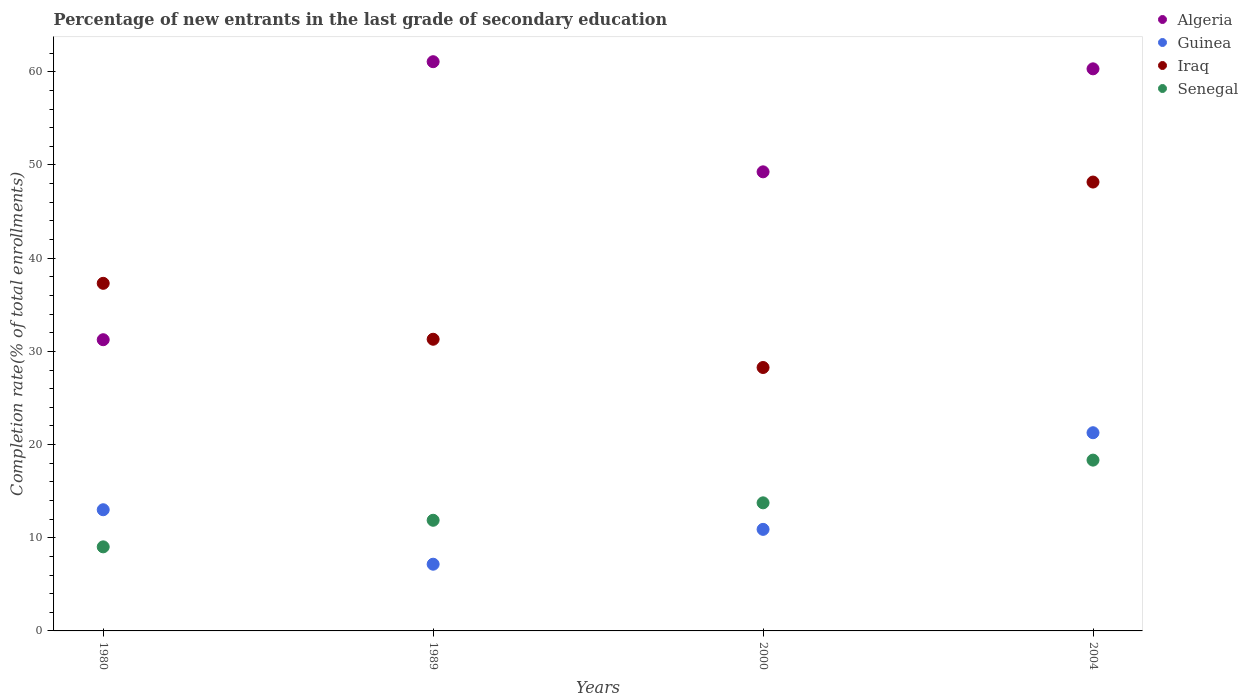How many different coloured dotlines are there?
Make the answer very short. 4. Is the number of dotlines equal to the number of legend labels?
Provide a succinct answer. Yes. What is the percentage of new entrants in Guinea in 1980?
Make the answer very short. 13. Across all years, what is the maximum percentage of new entrants in Iraq?
Offer a very short reply. 48.17. Across all years, what is the minimum percentage of new entrants in Algeria?
Provide a succinct answer. 31.25. In which year was the percentage of new entrants in Iraq maximum?
Provide a short and direct response. 2004. In which year was the percentage of new entrants in Algeria minimum?
Your response must be concise. 1980. What is the total percentage of new entrants in Senegal in the graph?
Your answer should be compact. 52.97. What is the difference between the percentage of new entrants in Senegal in 1989 and that in 2004?
Ensure brevity in your answer.  -6.45. What is the difference between the percentage of new entrants in Senegal in 2004 and the percentage of new entrants in Iraq in 1980?
Offer a terse response. -18.97. What is the average percentage of new entrants in Iraq per year?
Your answer should be compact. 36.26. In the year 1980, what is the difference between the percentage of new entrants in Senegal and percentage of new entrants in Iraq?
Offer a terse response. -28.28. What is the ratio of the percentage of new entrants in Senegal in 2000 to that in 2004?
Your response must be concise. 0.75. What is the difference between the highest and the second highest percentage of new entrants in Algeria?
Offer a terse response. 0.77. What is the difference between the highest and the lowest percentage of new entrants in Algeria?
Your answer should be very brief. 29.83. In how many years, is the percentage of new entrants in Iraq greater than the average percentage of new entrants in Iraq taken over all years?
Offer a terse response. 2. Is it the case that in every year, the sum of the percentage of new entrants in Iraq and percentage of new entrants in Guinea  is greater than the sum of percentage of new entrants in Senegal and percentage of new entrants in Algeria?
Provide a short and direct response. No. Is the percentage of new entrants in Guinea strictly greater than the percentage of new entrants in Algeria over the years?
Provide a succinct answer. No. Is the percentage of new entrants in Senegal strictly less than the percentage of new entrants in Guinea over the years?
Provide a succinct answer. No. How many years are there in the graph?
Make the answer very short. 4. Are the values on the major ticks of Y-axis written in scientific E-notation?
Keep it short and to the point. No. Does the graph contain grids?
Provide a short and direct response. No. Where does the legend appear in the graph?
Ensure brevity in your answer.  Top right. How are the legend labels stacked?
Provide a short and direct response. Vertical. What is the title of the graph?
Offer a very short reply. Percentage of new entrants in the last grade of secondary education. Does "Lower middle income" appear as one of the legend labels in the graph?
Offer a very short reply. No. What is the label or title of the X-axis?
Provide a succinct answer. Years. What is the label or title of the Y-axis?
Keep it short and to the point. Completion rate(% of total enrollments). What is the Completion rate(% of total enrollments) in Algeria in 1980?
Provide a short and direct response. 31.25. What is the Completion rate(% of total enrollments) of Guinea in 1980?
Give a very brief answer. 13. What is the Completion rate(% of total enrollments) in Iraq in 1980?
Ensure brevity in your answer.  37.3. What is the Completion rate(% of total enrollments) of Senegal in 1980?
Keep it short and to the point. 9.02. What is the Completion rate(% of total enrollments) in Algeria in 1989?
Your response must be concise. 61.08. What is the Completion rate(% of total enrollments) of Guinea in 1989?
Ensure brevity in your answer.  7.16. What is the Completion rate(% of total enrollments) of Iraq in 1989?
Offer a very short reply. 31.3. What is the Completion rate(% of total enrollments) of Senegal in 1989?
Offer a very short reply. 11.87. What is the Completion rate(% of total enrollments) in Algeria in 2000?
Offer a very short reply. 49.27. What is the Completion rate(% of total enrollments) in Guinea in 2000?
Ensure brevity in your answer.  10.9. What is the Completion rate(% of total enrollments) of Iraq in 2000?
Offer a very short reply. 28.27. What is the Completion rate(% of total enrollments) of Senegal in 2000?
Your answer should be compact. 13.74. What is the Completion rate(% of total enrollments) of Algeria in 2004?
Ensure brevity in your answer.  60.32. What is the Completion rate(% of total enrollments) of Guinea in 2004?
Make the answer very short. 21.27. What is the Completion rate(% of total enrollments) in Iraq in 2004?
Your answer should be compact. 48.17. What is the Completion rate(% of total enrollments) of Senegal in 2004?
Your answer should be compact. 18.33. Across all years, what is the maximum Completion rate(% of total enrollments) of Algeria?
Keep it short and to the point. 61.08. Across all years, what is the maximum Completion rate(% of total enrollments) in Guinea?
Ensure brevity in your answer.  21.27. Across all years, what is the maximum Completion rate(% of total enrollments) of Iraq?
Your response must be concise. 48.17. Across all years, what is the maximum Completion rate(% of total enrollments) of Senegal?
Offer a very short reply. 18.33. Across all years, what is the minimum Completion rate(% of total enrollments) in Algeria?
Provide a succinct answer. 31.25. Across all years, what is the minimum Completion rate(% of total enrollments) in Guinea?
Your answer should be very brief. 7.16. Across all years, what is the minimum Completion rate(% of total enrollments) in Iraq?
Offer a terse response. 28.27. Across all years, what is the minimum Completion rate(% of total enrollments) in Senegal?
Offer a terse response. 9.02. What is the total Completion rate(% of total enrollments) in Algeria in the graph?
Offer a very short reply. 201.92. What is the total Completion rate(% of total enrollments) in Guinea in the graph?
Your answer should be very brief. 52.33. What is the total Completion rate(% of total enrollments) in Iraq in the graph?
Offer a very short reply. 145.04. What is the total Completion rate(% of total enrollments) of Senegal in the graph?
Offer a very short reply. 52.97. What is the difference between the Completion rate(% of total enrollments) in Algeria in 1980 and that in 1989?
Your answer should be very brief. -29.83. What is the difference between the Completion rate(% of total enrollments) in Guinea in 1980 and that in 1989?
Your answer should be compact. 5.84. What is the difference between the Completion rate(% of total enrollments) in Iraq in 1980 and that in 1989?
Keep it short and to the point. 6. What is the difference between the Completion rate(% of total enrollments) of Senegal in 1980 and that in 1989?
Offer a terse response. -2.85. What is the difference between the Completion rate(% of total enrollments) of Algeria in 1980 and that in 2000?
Keep it short and to the point. -18.02. What is the difference between the Completion rate(% of total enrollments) in Guinea in 1980 and that in 2000?
Your answer should be compact. 2.11. What is the difference between the Completion rate(% of total enrollments) in Iraq in 1980 and that in 2000?
Ensure brevity in your answer.  9.03. What is the difference between the Completion rate(% of total enrollments) in Senegal in 1980 and that in 2000?
Ensure brevity in your answer.  -4.72. What is the difference between the Completion rate(% of total enrollments) in Algeria in 1980 and that in 2004?
Offer a very short reply. -29.07. What is the difference between the Completion rate(% of total enrollments) in Guinea in 1980 and that in 2004?
Offer a very short reply. -8.26. What is the difference between the Completion rate(% of total enrollments) in Iraq in 1980 and that in 2004?
Your answer should be compact. -10.87. What is the difference between the Completion rate(% of total enrollments) of Senegal in 1980 and that in 2004?
Your answer should be compact. -9.31. What is the difference between the Completion rate(% of total enrollments) of Algeria in 1989 and that in 2000?
Provide a short and direct response. 11.82. What is the difference between the Completion rate(% of total enrollments) of Guinea in 1989 and that in 2000?
Provide a short and direct response. -3.74. What is the difference between the Completion rate(% of total enrollments) of Iraq in 1989 and that in 2000?
Ensure brevity in your answer.  3.03. What is the difference between the Completion rate(% of total enrollments) of Senegal in 1989 and that in 2000?
Give a very brief answer. -1.87. What is the difference between the Completion rate(% of total enrollments) of Algeria in 1989 and that in 2004?
Offer a terse response. 0.77. What is the difference between the Completion rate(% of total enrollments) of Guinea in 1989 and that in 2004?
Ensure brevity in your answer.  -14.11. What is the difference between the Completion rate(% of total enrollments) in Iraq in 1989 and that in 2004?
Provide a short and direct response. -16.87. What is the difference between the Completion rate(% of total enrollments) in Senegal in 1989 and that in 2004?
Ensure brevity in your answer.  -6.45. What is the difference between the Completion rate(% of total enrollments) of Algeria in 2000 and that in 2004?
Your answer should be very brief. -11.05. What is the difference between the Completion rate(% of total enrollments) of Guinea in 2000 and that in 2004?
Give a very brief answer. -10.37. What is the difference between the Completion rate(% of total enrollments) in Iraq in 2000 and that in 2004?
Give a very brief answer. -19.9. What is the difference between the Completion rate(% of total enrollments) in Senegal in 2000 and that in 2004?
Your answer should be very brief. -4.58. What is the difference between the Completion rate(% of total enrollments) of Algeria in 1980 and the Completion rate(% of total enrollments) of Guinea in 1989?
Offer a very short reply. 24.09. What is the difference between the Completion rate(% of total enrollments) in Algeria in 1980 and the Completion rate(% of total enrollments) in Iraq in 1989?
Your answer should be compact. -0.05. What is the difference between the Completion rate(% of total enrollments) in Algeria in 1980 and the Completion rate(% of total enrollments) in Senegal in 1989?
Ensure brevity in your answer.  19.38. What is the difference between the Completion rate(% of total enrollments) in Guinea in 1980 and the Completion rate(% of total enrollments) in Iraq in 1989?
Your answer should be very brief. -18.3. What is the difference between the Completion rate(% of total enrollments) of Guinea in 1980 and the Completion rate(% of total enrollments) of Senegal in 1989?
Offer a very short reply. 1.13. What is the difference between the Completion rate(% of total enrollments) in Iraq in 1980 and the Completion rate(% of total enrollments) in Senegal in 1989?
Give a very brief answer. 25.43. What is the difference between the Completion rate(% of total enrollments) in Algeria in 1980 and the Completion rate(% of total enrollments) in Guinea in 2000?
Your answer should be compact. 20.35. What is the difference between the Completion rate(% of total enrollments) in Algeria in 1980 and the Completion rate(% of total enrollments) in Iraq in 2000?
Ensure brevity in your answer.  2.98. What is the difference between the Completion rate(% of total enrollments) of Algeria in 1980 and the Completion rate(% of total enrollments) of Senegal in 2000?
Give a very brief answer. 17.5. What is the difference between the Completion rate(% of total enrollments) in Guinea in 1980 and the Completion rate(% of total enrollments) in Iraq in 2000?
Offer a very short reply. -15.26. What is the difference between the Completion rate(% of total enrollments) in Guinea in 1980 and the Completion rate(% of total enrollments) in Senegal in 2000?
Your response must be concise. -0.74. What is the difference between the Completion rate(% of total enrollments) in Iraq in 1980 and the Completion rate(% of total enrollments) in Senegal in 2000?
Ensure brevity in your answer.  23.56. What is the difference between the Completion rate(% of total enrollments) of Algeria in 1980 and the Completion rate(% of total enrollments) of Guinea in 2004?
Give a very brief answer. 9.98. What is the difference between the Completion rate(% of total enrollments) in Algeria in 1980 and the Completion rate(% of total enrollments) in Iraq in 2004?
Your answer should be very brief. -16.92. What is the difference between the Completion rate(% of total enrollments) of Algeria in 1980 and the Completion rate(% of total enrollments) of Senegal in 2004?
Keep it short and to the point. 12.92. What is the difference between the Completion rate(% of total enrollments) of Guinea in 1980 and the Completion rate(% of total enrollments) of Iraq in 2004?
Offer a very short reply. -35.16. What is the difference between the Completion rate(% of total enrollments) of Guinea in 1980 and the Completion rate(% of total enrollments) of Senegal in 2004?
Give a very brief answer. -5.33. What is the difference between the Completion rate(% of total enrollments) in Iraq in 1980 and the Completion rate(% of total enrollments) in Senegal in 2004?
Your answer should be very brief. 18.97. What is the difference between the Completion rate(% of total enrollments) of Algeria in 1989 and the Completion rate(% of total enrollments) of Guinea in 2000?
Make the answer very short. 50.19. What is the difference between the Completion rate(% of total enrollments) of Algeria in 1989 and the Completion rate(% of total enrollments) of Iraq in 2000?
Your answer should be compact. 32.82. What is the difference between the Completion rate(% of total enrollments) in Algeria in 1989 and the Completion rate(% of total enrollments) in Senegal in 2000?
Offer a terse response. 47.34. What is the difference between the Completion rate(% of total enrollments) in Guinea in 1989 and the Completion rate(% of total enrollments) in Iraq in 2000?
Provide a short and direct response. -21.11. What is the difference between the Completion rate(% of total enrollments) of Guinea in 1989 and the Completion rate(% of total enrollments) of Senegal in 2000?
Ensure brevity in your answer.  -6.59. What is the difference between the Completion rate(% of total enrollments) of Iraq in 1989 and the Completion rate(% of total enrollments) of Senegal in 2000?
Give a very brief answer. 17.55. What is the difference between the Completion rate(% of total enrollments) in Algeria in 1989 and the Completion rate(% of total enrollments) in Guinea in 2004?
Give a very brief answer. 39.82. What is the difference between the Completion rate(% of total enrollments) of Algeria in 1989 and the Completion rate(% of total enrollments) of Iraq in 2004?
Give a very brief answer. 12.92. What is the difference between the Completion rate(% of total enrollments) in Algeria in 1989 and the Completion rate(% of total enrollments) in Senegal in 2004?
Provide a succinct answer. 42.76. What is the difference between the Completion rate(% of total enrollments) of Guinea in 1989 and the Completion rate(% of total enrollments) of Iraq in 2004?
Your response must be concise. -41.01. What is the difference between the Completion rate(% of total enrollments) of Guinea in 1989 and the Completion rate(% of total enrollments) of Senegal in 2004?
Make the answer very short. -11.17. What is the difference between the Completion rate(% of total enrollments) in Iraq in 1989 and the Completion rate(% of total enrollments) in Senegal in 2004?
Offer a very short reply. 12.97. What is the difference between the Completion rate(% of total enrollments) in Algeria in 2000 and the Completion rate(% of total enrollments) in Guinea in 2004?
Keep it short and to the point. 28. What is the difference between the Completion rate(% of total enrollments) of Algeria in 2000 and the Completion rate(% of total enrollments) of Iraq in 2004?
Ensure brevity in your answer.  1.1. What is the difference between the Completion rate(% of total enrollments) in Algeria in 2000 and the Completion rate(% of total enrollments) in Senegal in 2004?
Provide a short and direct response. 30.94. What is the difference between the Completion rate(% of total enrollments) of Guinea in 2000 and the Completion rate(% of total enrollments) of Iraq in 2004?
Keep it short and to the point. -37.27. What is the difference between the Completion rate(% of total enrollments) in Guinea in 2000 and the Completion rate(% of total enrollments) in Senegal in 2004?
Your answer should be very brief. -7.43. What is the difference between the Completion rate(% of total enrollments) of Iraq in 2000 and the Completion rate(% of total enrollments) of Senegal in 2004?
Offer a terse response. 9.94. What is the average Completion rate(% of total enrollments) of Algeria per year?
Offer a terse response. 50.48. What is the average Completion rate(% of total enrollments) of Guinea per year?
Provide a succinct answer. 13.08. What is the average Completion rate(% of total enrollments) in Iraq per year?
Your response must be concise. 36.26. What is the average Completion rate(% of total enrollments) of Senegal per year?
Make the answer very short. 13.24. In the year 1980, what is the difference between the Completion rate(% of total enrollments) in Algeria and Completion rate(% of total enrollments) in Guinea?
Your response must be concise. 18.25. In the year 1980, what is the difference between the Completion rate(% of total enrollments) in Algeria and Completion rate(% of total enrollments) in Iraq?
Offer a very short reply. -6.05. In the year 1980, what is the difference between the Completion rate(% of total enrollments) of Algeria and Completion rate(% of total enrollments) of Senegal?
Offer a terse response. 22.23. In the year 1980, what is the difference between the Completion rate(% of total enrollments) in Guinea and Completion rate(% of total enrollments) in Iraq?
Give a very brief answer. -24.3. In the year 1980, what is the difference between the Completion rate(% of total enrollments) in Guinea and Completion rate(% of total enrollments) in Senegal?
Your answer should be compact. 3.98. In the year 1980, what is the difference between the Completion rate(% of total enrollments) of Iraq and Completion rate(% of total enrollments) of Senegal?
Your response must be concise. 28.28. In the year 1989, what is the difference between the Completion rate(% of total enrollments) of Algeria and Completion rate(% of total enrollments) of Guinea?
Give a very brief answer. 53.93. In the year 1989, what is the difference between the Completion rate(% of total enrollments) in Algeria and Completion rate(% of total enrollments) in Iraq?
Provide a short and direct response. 29.78. In the year 1989, what is the difference between the Completion rate(% of total enrollments) in Algeria and Completion rate(% of total enrollments) in Senegal?
Offer a very short reply. 49.21. In the year 1989, what is the difference between the Completion rate(% of total enrollments) of Guinea and Completion rate(% of total enrollments) of Iraq?
Your response must be concise. -24.14. In the year 1989, what is the difference between the Completion rate(% of total enrollments) of Guinea and Completion rate(% of total enrollments) of Senegal?
Your response must be concise. -4.72. In the year 1989, what is the difference between the Completion rate(% of total enrollments) of Iraq and Completion rate(% of total enrollments) of Senegal?
Your response must be concise. 19.43. In the year 2000, what is the difference between the Completion rate(% of total enrollments) of Algeria and Completion rate(% of total enrollments) of Guinea?
Your answer should be very brief. 38.37. In the year 2000, what is the difference between the Completion rate(% of total enrollments) in Algeria and Completion rate(% of total enrollments) in Iraq?
Your answer should be compact. 21. In the year 2000, what is the difference between the Completion rate(% of total enrollments) in Algeria and Completion rate(% of total enrollments) in Senegal?
Your answer should be very brief. 35.52. In the year 2000, what is the difference between the Completion rate(% of total enrollments) in Guinea and Completion rate(% of total enrollments) in Iraq?
Ensure brevity in your answer.  -17.37. In the year 2000, what is the difference between the Completion rate(% of total enrollments) of Guinea and Completion rate(% of total enrollments) of Senegal?
Your answer should be very brief. -2.85. In the year 2000, what is the difference between the Completion rate(% of total enrollments) in Iraq and Completion rate(% of total enrollments) in Senegal?
Your response must be concise. 14.52. In the year 2004, what is the difference between the Completion rate(% of total enrollments) of Algeria and Completion rate(% of total enrollments) of Guinea?
Your answer should be compact. 39.05. In the year 2004, what is the difference between the Completion rate(% of total enrollments) of Algeria and Completion rate(% of total enrollments) of Iraq?
Offer a terse response. 12.15. In the year 2004, what is the difference between the Completion rate(% of total enrollments) of Algeria and Completion rate(% of total enrollments) of Senegal?
Give a very brief answer. 41.99. In the year 2004, what is the difference between the Completion rate(% of total enrollments) in Guinea and Completion rate(% of total enrollments) in Iraq?
Keep it short and to the point. -26.9. In the year 2004, what is the difference between the Completion rate(% of total enrollments) of Guinea and Completion rate(% of total enrollments) of Senegal?
Keep it short and to the point. 2.94. In the year 2004, what is the difference between the Completion rate(% of total enrollments) of Iraq and Completion rate(% of total enrollments) of Senegal?
Your response must be concise. 29.84. What is the ratio of the Completion rate(% of total enrollments) of Algeria in 1980 to that in 1989?
Offer a terse response. 0.51. What is the ratio of the Completion rate(% of total enrollments) of Guinea in 1980 to that in 1989?
Offer a very short reply. 1.82. What is the ratio of the Completion rate(% of total enrollments) in Iraq in 1980 to that in 1989?
Offer a terse response. 1.19. What is the ratio of the Completion rate(% of total enrollments) of Senegal in 1980 to that in 1989?
Your answer should be compact. 0.76. What is the ratio of the Completion rate(% of total enrollments) of Algeria in 1980 to that in 2000?
Give a very brief answer. 0.63. What is the ratio of the Completion rate(% of total enrollments) of Guinea in 1980 to that in 2000?
Ensure brevity in your answer.  1.19. What is the ratio of the Completion rate(% of total enrollments) in Iraq in 1980 to that in 2000?
Ensure brevity in your answer.  1.32. What is the ratio of the Completion rate(% of total enrollments) in Senegal in 1980 to that in 2000?
Offer a very short reply. 0.66. What is the ratio of the Completion rate(% of total enrollments) in Algeria in 1980 to that in 2004?
Offer a very short reply. 0.52. What is the ratio of the Completion rate(% of total enrollments) in Guinea in 1980 to that in 2004?
Your answer should be very brief. 0.61. What is the ratio of the Completion rate(% of total enrollments) of Iraq in 1980 to that in 2004?
Keep it short and to the point. 0.77. What is the ratio of the Completion rate(% of total enrollments) in Senegal in 1980 to that in 2004?
Provide a succinct answer. 0.49. What is the ratio of the Completion rate(% of total enrollments) in Algeria in 1989 to that in 2000?
Give a very brief answer. 1.24. What is the ratio of the Completion rate(% of total enrollments) in Guinea in 1989 to that in 2000?
Ensure brevity in your answer.  0.66. What is the ratio of the Completion rate(% of total enrollments) in Iraq in 1989 to that in 2000?
Make the answer very short. 1.11. What is the ratio of the Completion rate(% of total enrollments) of Senegal in 1989 to that in 2000?
Provide a short and direct response. 0.86. What is the ratio of the Completion rate(% of total enrollments) in Algeria in 1989 to that in 2004?
Provide a short and direct response. 1.01. What is the ratio of the Completion rate(% of total enrollments) in Guinea in 1989 to that in 2004?
Provide a succinct answer. 0.34. What is the ratio of the Completion rate(% of total enrollments) of Iraq in 1989 to that in 2004?
Provide a short and direct response. 0.65. What is the ratio of the Completion rate(% of total enrollments) in Senegal in 1989 to that in 2004?
Ensure brevity in your answer.  0.65. What is the ratio of the Completion rate(% of total enrollments) of Algeria in 2000 to that in 2004?
Offer a terse response. 0.82. What is the ratio of the Completion rate(% of total enrollments) in Guinea in 2000 to that in 2004?
Your answer should be compact. 0.51. What is the ratio of the Completion rate(% of total enrollments) of Iraq in 2000 to that in 2004?
Provide a succinct answer. 0.59. What is the ratio of the Completion rate(% of total enrollments) in Senegal in 2000 to that in 2004?
Offer a terse response. 0.75. What is the difference between the highest and the second highest Completion rate(% of total enrollments) of Algeria?
Make the answer very short. 0.77. What is the difference between the highest and the second highest Completion rate(% of total enrollments) in Guinea?
Your response must be concise. 8.26. What is the difference between the highest and the second highest Completion rate(% of total enrollments) of Iraq?
Provide a succinct answer. 10.87. What is the difference between the highest and the second highest Completion rate(% of total enrollments) in Senegal?
Offer a very short reply. 4.58. What is the difference between the highest and the lowest Completion rate(% of total enrollments) in Algeria?
Your answer should be very brief. 29.83. What is the difference between the highest and the lowest Completion rate(% of total enrollments) in Guinea?
Offer a terse response. 14.11. What is the difference between the highest and the lowest Completion rate(% of total enrollments) of Iraq?
Offer a very short reply. 19.9. What is the difference between the highest and the lowest Completion rate(% of total enrollments) in Senegal?
Keep it short and to the point. 9.31. 